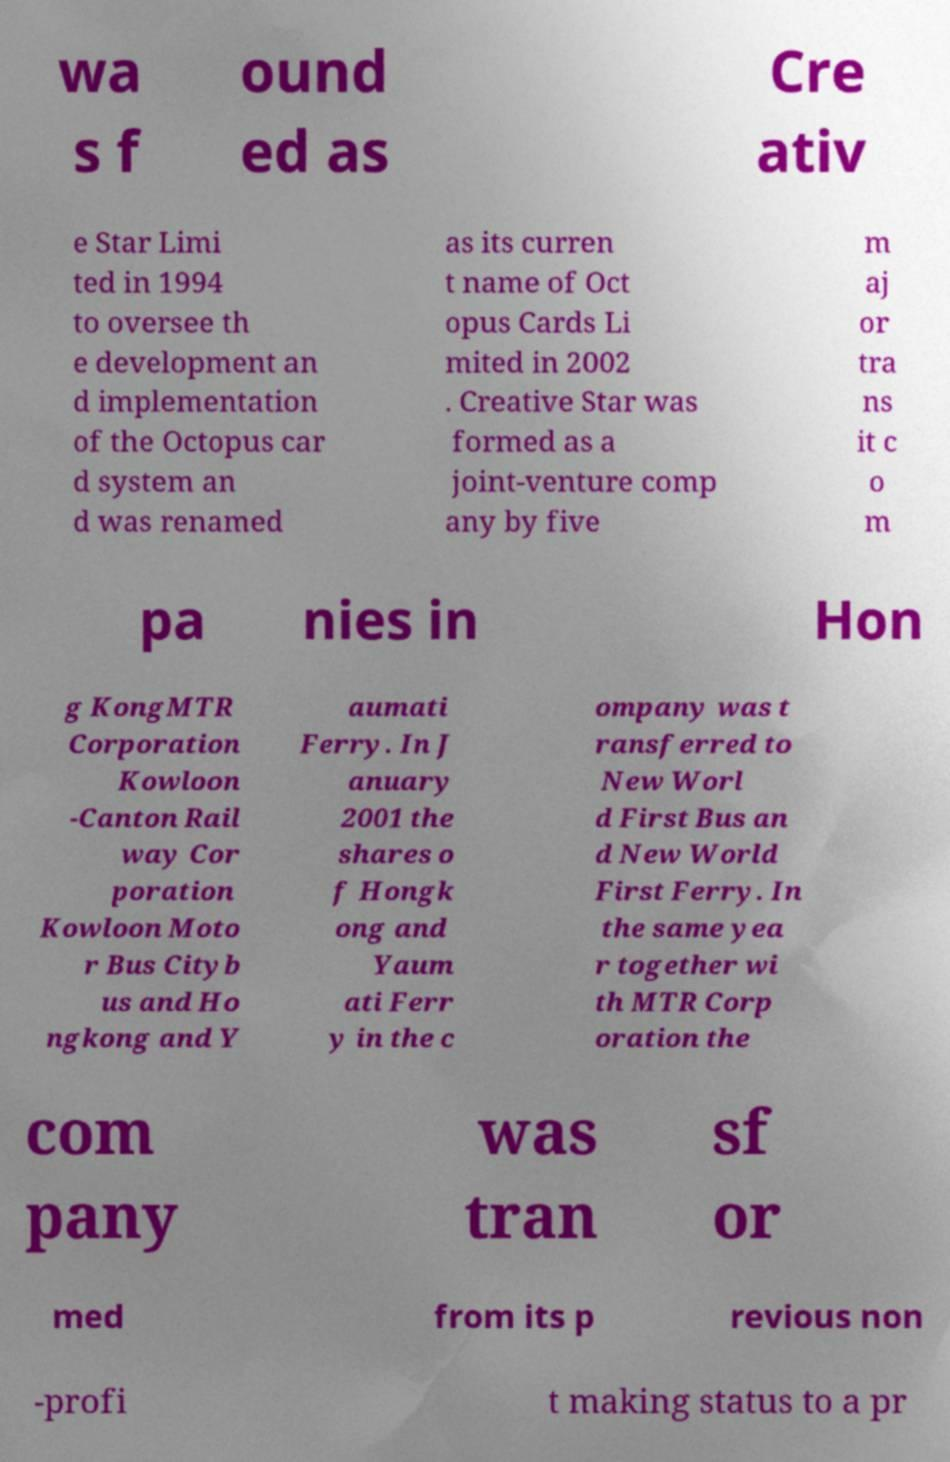Could you extract and type out the text from this image? wa s f ound ed as Cre ativ e Star Limi ted in 1994 to oversee th e development an d implementation of the Octopus car d system an d was renamed as its curren t name of Oct opus Cards Li mited in 2002 . Creative Star was formed as a joint-venture comp any by five m aj or tra ns it c o m pa nies in Hon g KongMTR Corporation Kowloon -Canton Rail way Cor poration Kowloon Moto r Bus Cityb us and Ho ngkong and Y aumati Ferry. In J anuary 2001 the shares o f Hongk ong and Yaum ati Ferr y in the c ompany was t ransferred to New Worl d First Bus an d New World First Ferry. In the same yea r together wi th MTR Corp oration the com pany was tran sf or med from its p revious non -profi t making status to a pr 